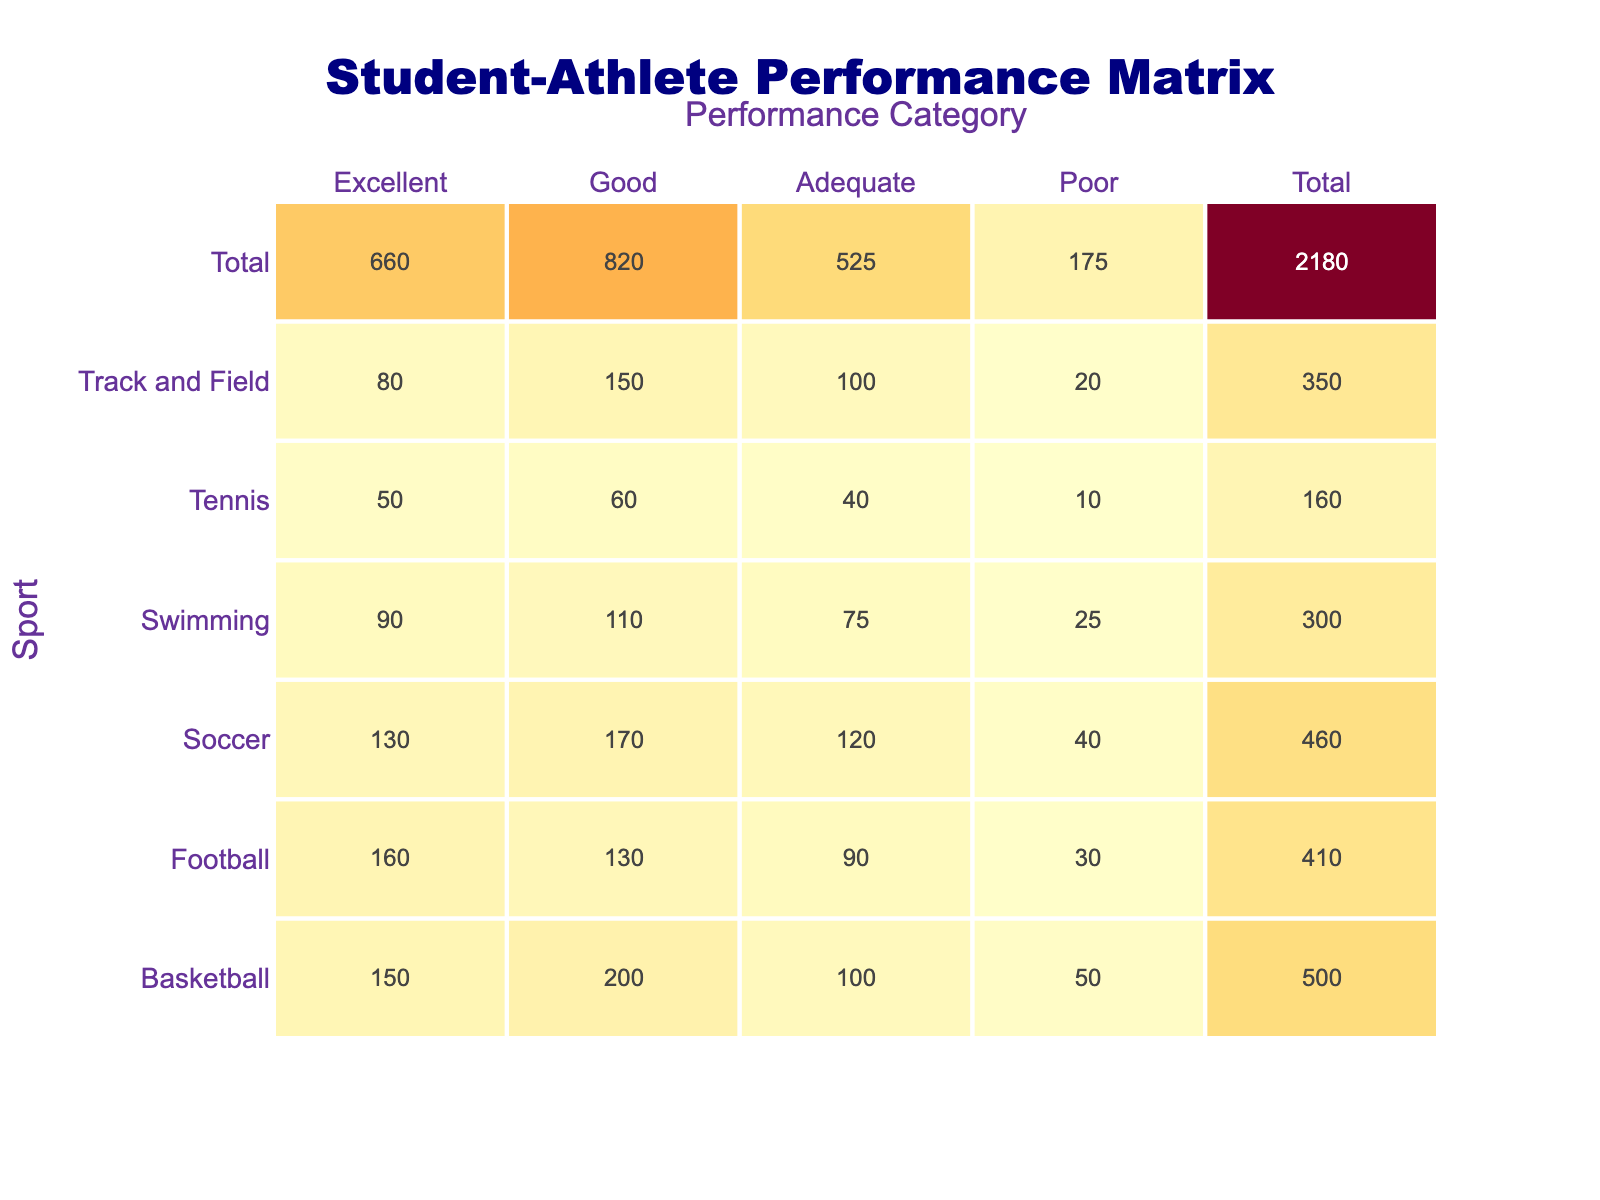What is the total number of student-athletes in Football? In the table, the counts for Football across Performance Categories are: Excellent (160), Good (130), Adequate (90), and Poor (30). To find the total number, we sum these values: 160 + 130 + 90 + 30 = 410.
Answer: 410 Which sport has the highest count of student-athletes in the Excellent performance category? Referring to the Excellent category, Basketball has 150, Soccer has 130, Track and Field has 80, Swimming has 90, Football has 160, and Tennis has 50. The highest is Football with 160.
Answer: Football Is the number of student-athletes categorized as Poor in Tennis greater than in Swimming? Tennis shows a count of 10 in Poor while Swimming has a count of 25. Since 10 is less than 25, the statement is false.
Answer: No What is the average count of student-athletes across all performance categories for Track and Field? The counts for Track and Field in categories are: Excellent (80), Good (150), Adequate (100), and Poor (20). Summing these gives 80 + 150 + 100 + 20 = 350. There are 4 categories, so the average is 350/4 = 87.5.
Answer: 87.5 How many more student-athletes performed at an Excellent level in Basketball compared to Poor in Track and Field? Excellent in Basketball is 150 and Poor in Track and Field is 20. The difference is calculated as: 150 - 20 = 130.
Answer: 130 Which sports have more than 100 student-athletes categorized as Good? The sports with counts greater than 100 in Good are Basketball (200), Soccer (170), Track and Field (150), and Swimming (110). Therefore, these four sports meet the criteria.
Answer: Basketball, Soccer, Track and Field, Swimming Has the total number of student-athletes across all sports in the Adequate category exceeded 400? The counts for Adequate are: Basketball (100), Soccer (120), Track and Field (100), Swimming (75), Football (90), and Tennis (40). Summing these yields: 100 + 120 + 100 + 75 + 90 + 40 = 525, which exceeds 400.
Answer: Yes What percentage of Football players are categorized as Poor? The count of Poor in Football is 30 out of a total of 410 student-athletes. To find the percentage, we compute (30/410) * 100, which equals approximately 7.32%.
Answer: ~7.32% Which sport has the largest total number of student-athletes, and what is that number? The totals for each sport are Basketball (500), Soccer (460), Track and Field (350), Swimming (295), Football (410), and Tennis (160). The largest total is Basketball with 500.
Answer: Basketball, 500 